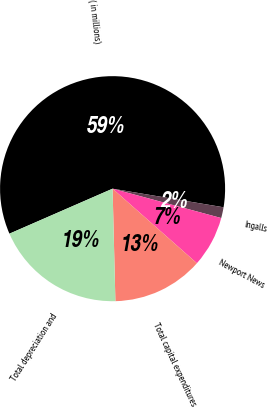Convert chart to OTSL. <chart><loc_0><loc_0><loc_500><loc_500><pie_chart><fcel>( in millions)<fcel>Ingalls<fcel>Newport News<fcel>Total capital expenditures<fcel>Total depreciation and<nl><fcel>59.19%<fcel>1.56%<fcel>7.32%<fcel>13.08%<fcel>18.85%<nl></chart> 